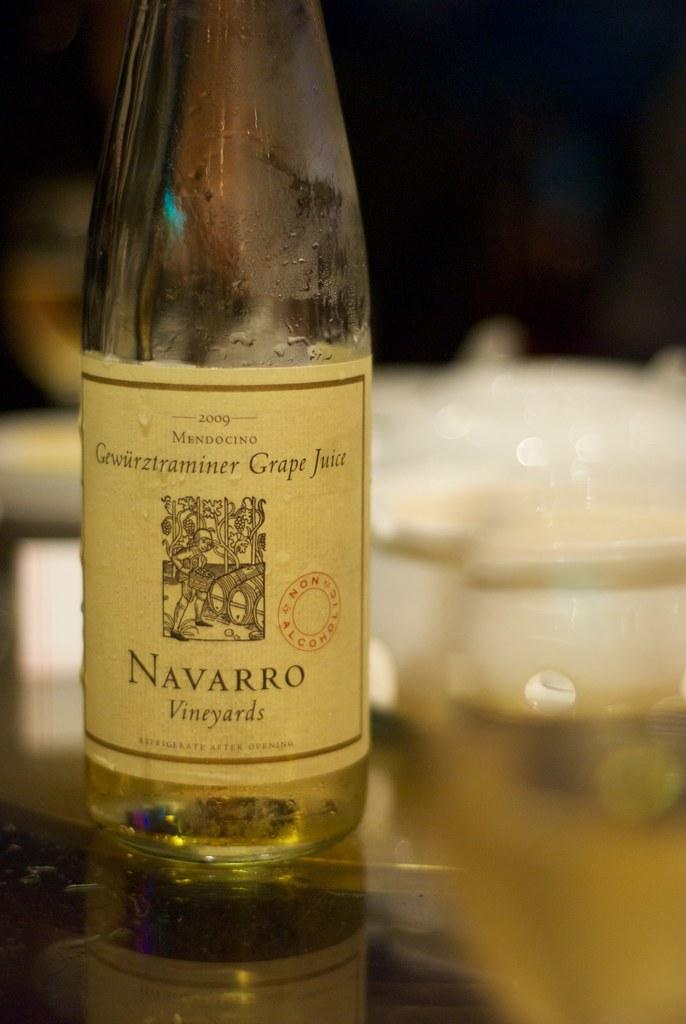What is the name of the vinyard?
Your answer should be very brief. Navarro. When was this made?
Provide a succinct answer. 2009. 